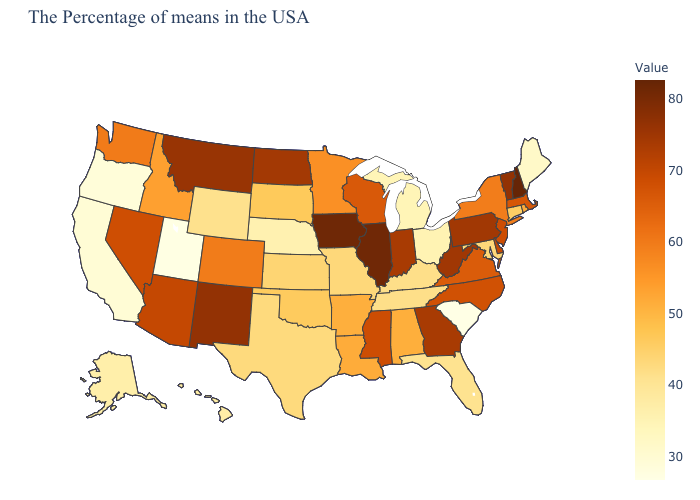Among the states that border Nevada , does Utah have the highest value?
Short answer required. No. Which states have the lowest value in the USA?
Short answer required. South Carolina. Among the states that border Utah , which have the highest value?
Be succinct. New Mexico. Does Oklahoma have the lowest value in the USA?
Write a very short answer. No. 